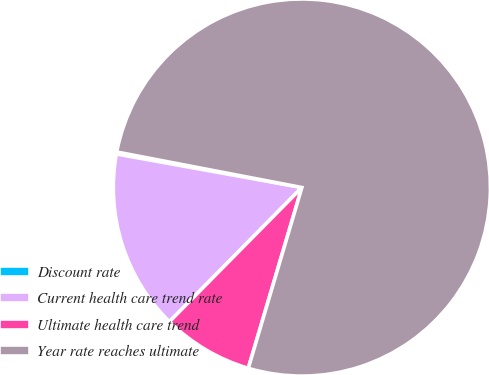Convert chart to OTSL. <chart><loc_0><loc_0><loc_500><loc_500><pie_chart><fcel>Discount rate<fcel>Current health care trend rate<fcel>Ultimate health care trend<fcel>Year rate reaches ultimate<nl><fcel>0.17%<fcel>15.45%<fcel>7.81%<fcel>76.56%<nl></chart> 